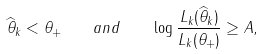Convert formula to latex. <formula><loc_0><loc_0><loc_500><loc_500>\widehat { \theta } _ { k } < \theta _ { + } \quad a n d \quad \log \frac { L _ { k } ( \widehat { \theta } _ { k } ) } { L _ { k } ( \theta _ { + } ) } \geq A ,</formula> 